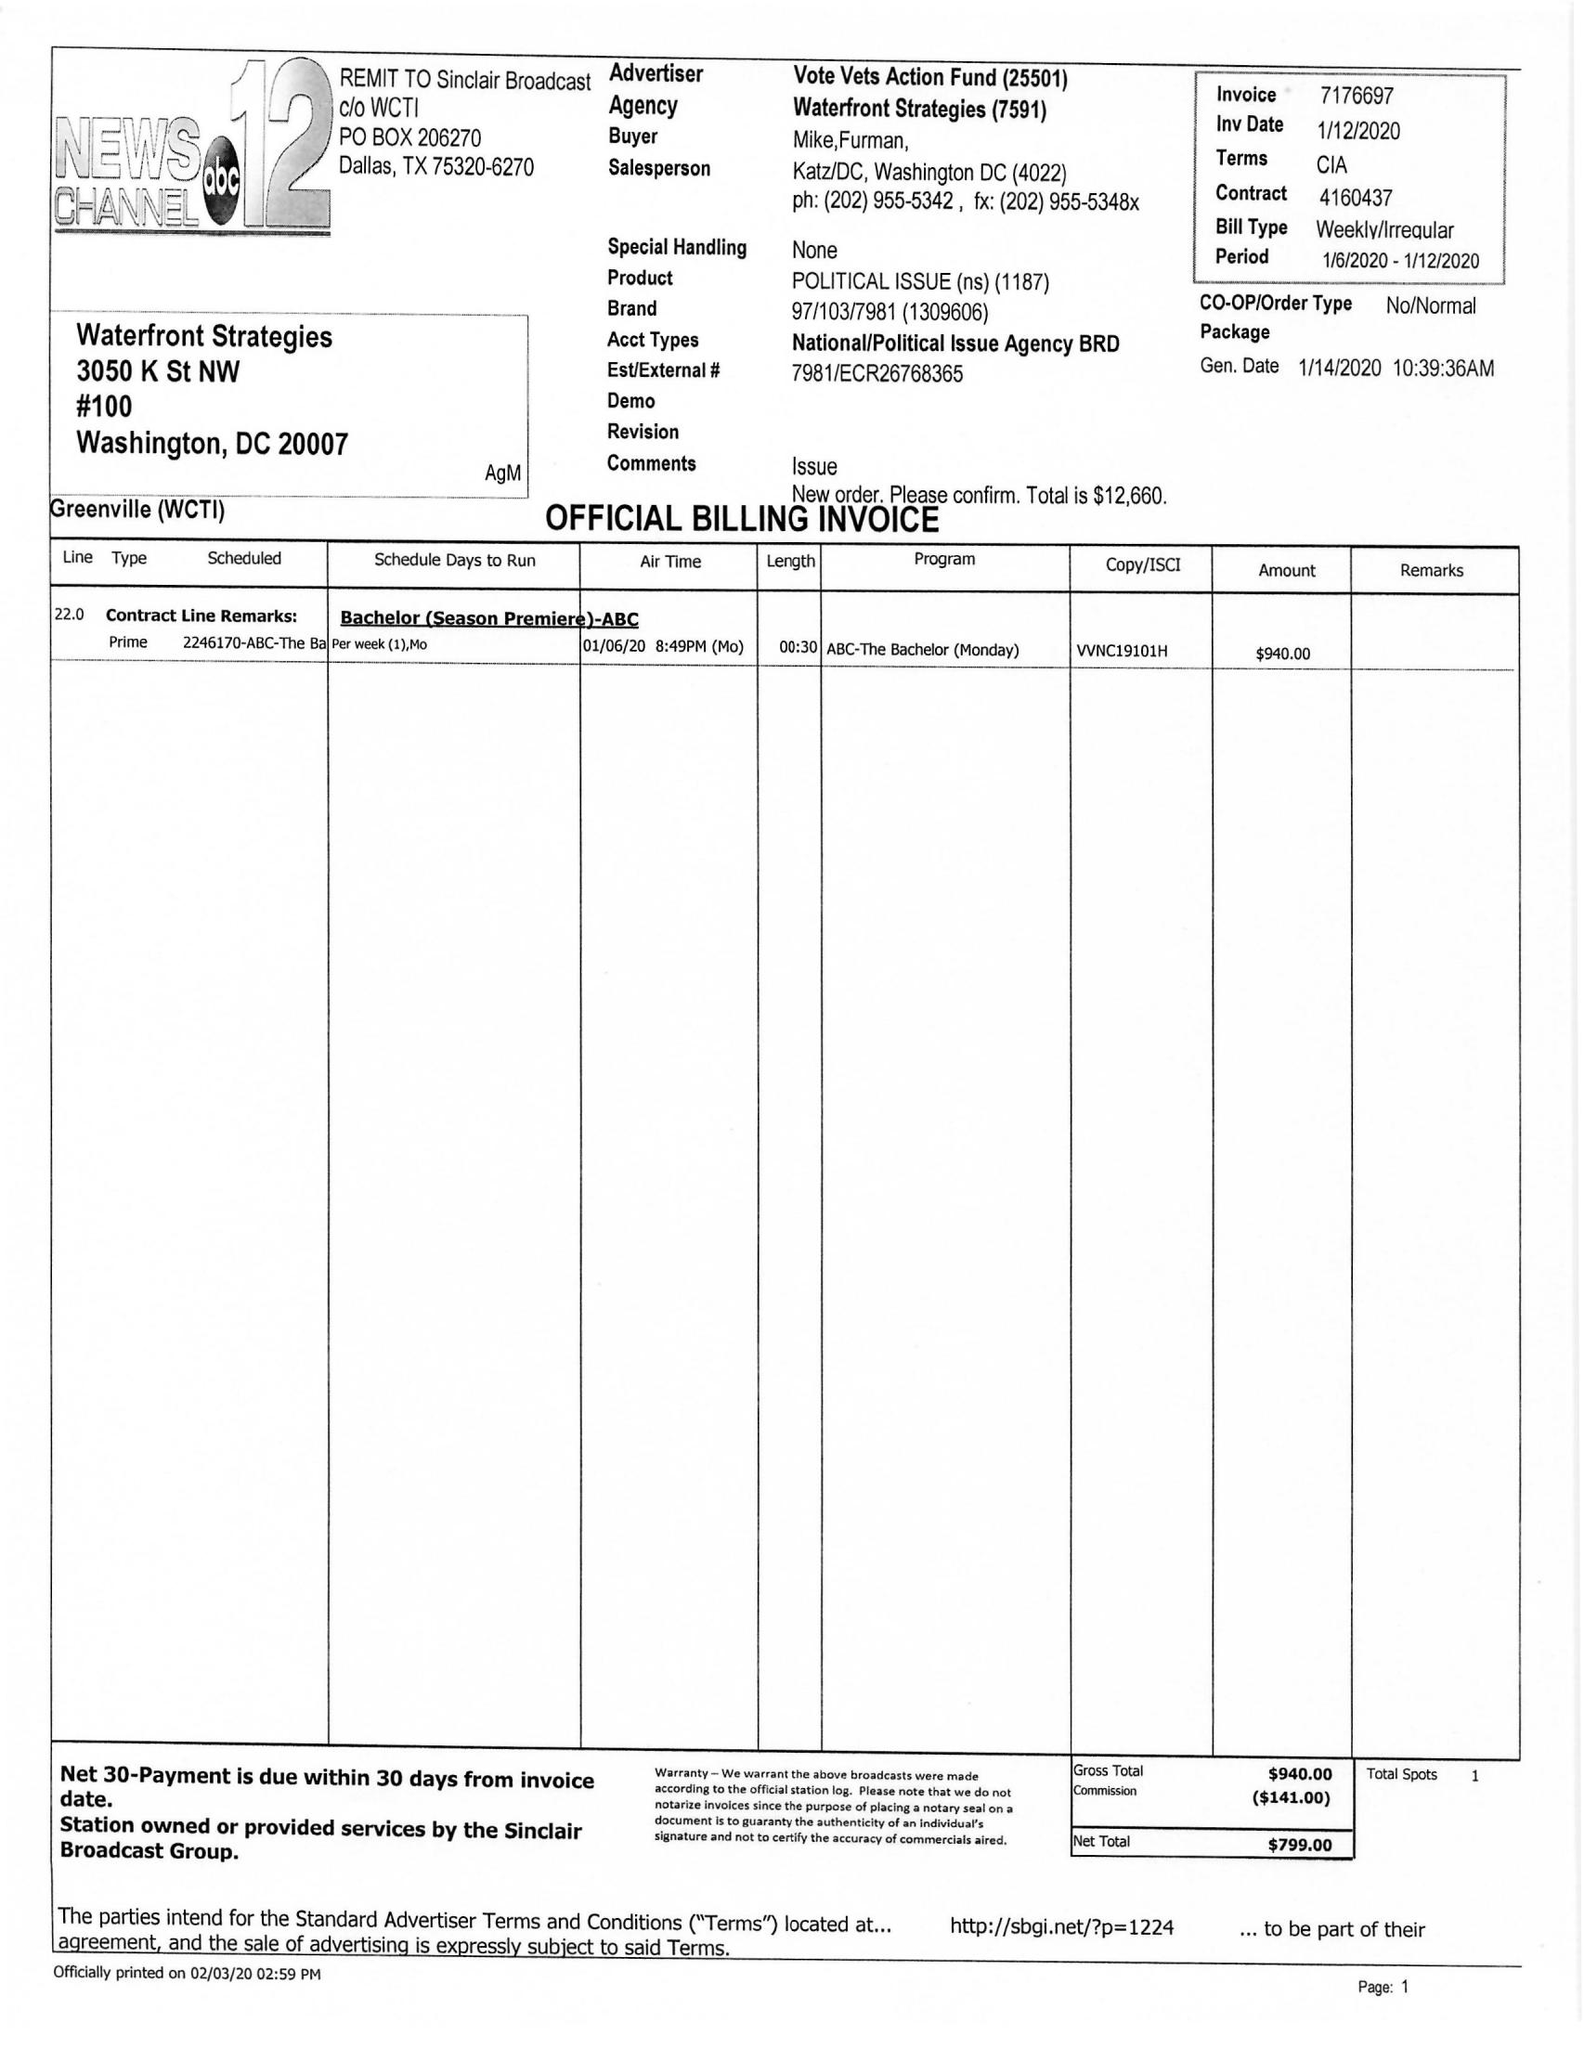What is the value for the flight_to?
Answer the question using a single word or phrase. 01/12/20 